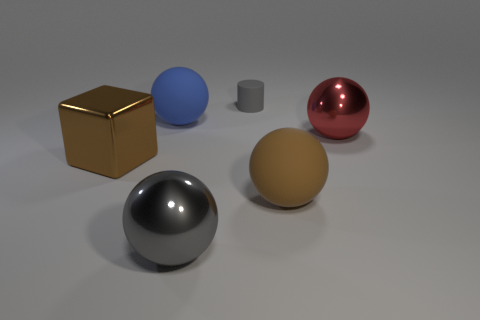What number of things are either big metal objects that are right of the gray matte thing or small blue shiny objects?
Your response must be concise. 1. What is the size of the brown rubber object?
Your answer should be very brief. Large. What material is the sphere right of the large matte ball that is in front of the large blue matte object?
Your answer should be very brief. Metal. Does the brown thing that is to the left of the blue thing have the same size as the gray metallic object?
Give a very brief answer. Yes. Are there any metallic balls of the same color as the tiny cylinder?
Ensure brevity in your answer.  Yes. How many things are things that are right of the brown sphere or big metal things left of the red object?
Ensure brevity in your answer.  3. There is a object that is the same color as the large block; what is it made of?
Keep it short and to the point. Rubber. Is the number of tiny gray matte cylinders in front of the large blue rubber object less than the number of matte things that are behind the metallic cube?
Your answer should be compact. Yes. Do the brown cube and the tiny thing have the same material?
Keep it short and to the point. No. There is a metal thing that is right of the large blue matte object and left of the big red ball; what size is it?
Give a very brief answer. Large. 